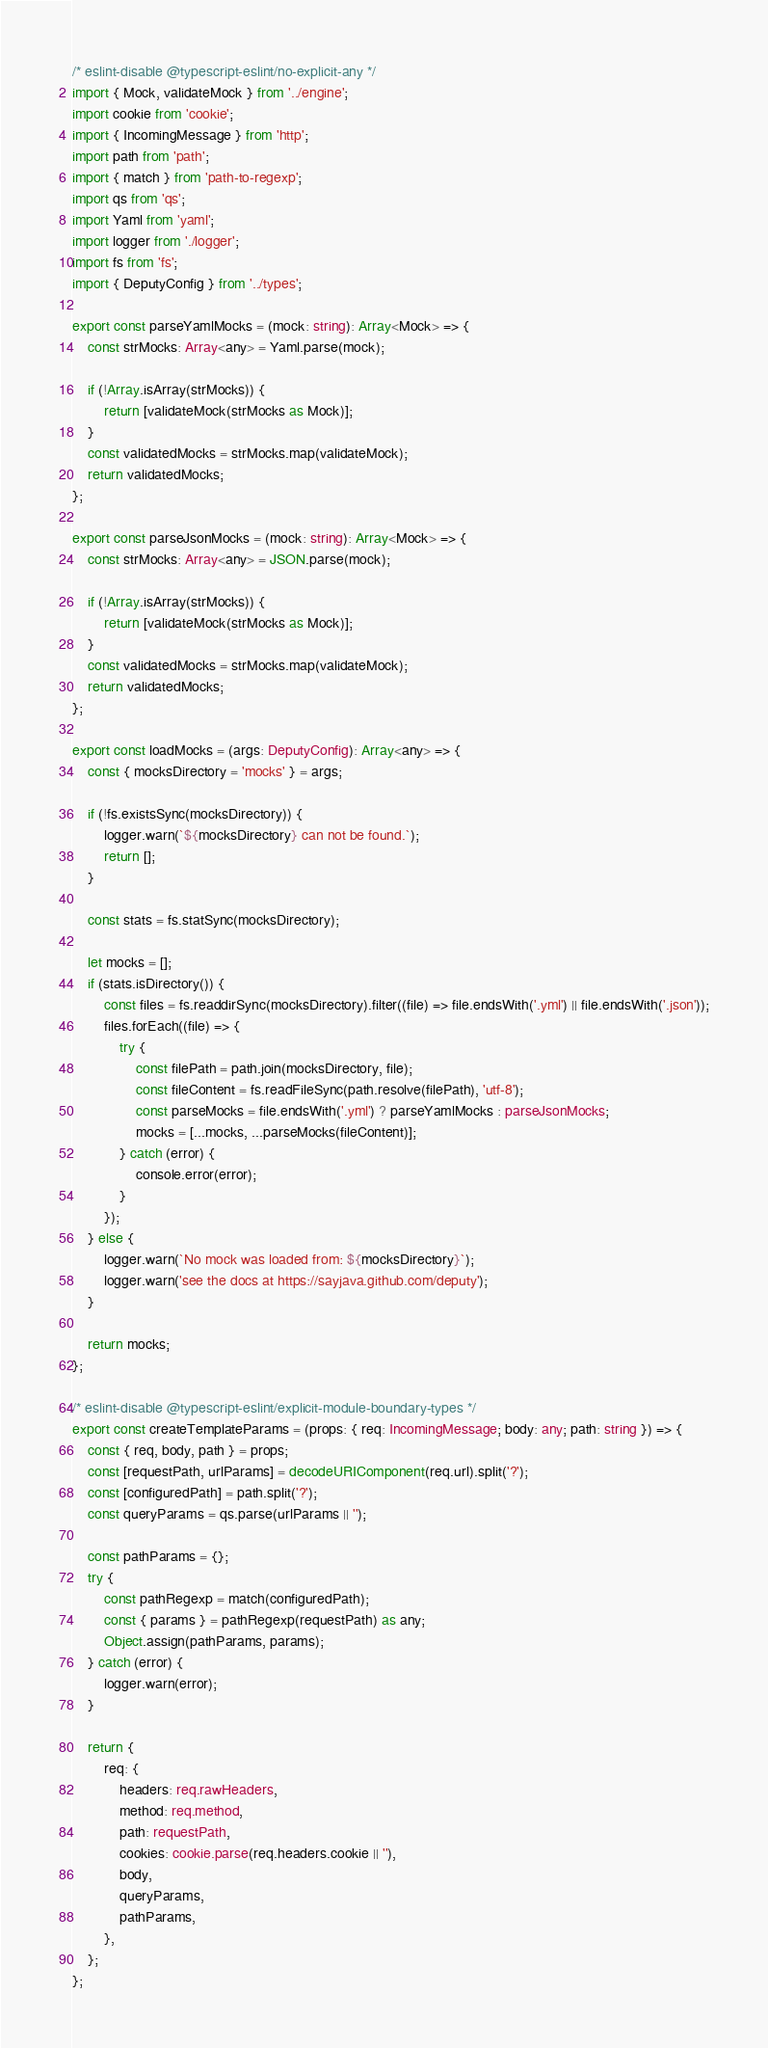<code> <loc_0><loc_0><loc_500><loc_500><_TypeScript_>/* eslint-disable @typescript-eslint/no-explicit-any */
import { Mock, validateMock } from '../engine';
import cookie from 'cookie';
import { IncomingMessage } from 'http';
import path from 'path';
import { match } from 'path-to-regexp';
import qs from 'qs';
import Yaml from 'yaml';
import logger from './logger';
import fs from 'fs';
import { DeputyConfig } from '../types';

export const parseYamlMocks = (mock: string): Array<Mock> => {
    const strMocks: Array<any> = Yaml.parse(mock);

    if (!Array.isArray(strMocks)) {
        return [validateMock(strMocks as Mock)];
    }
    const validatedMocks = strMocks.map(validateMock);
    return validatedMocks;
};

export const parseJsonMocks = (mock: string): Array<Mock> => {
    const strMocks: Array<any> = JSON.parse(mock);

    if (!Array.isArray(strMocks)) {
        return [validateMock(strMocks as Mock)];
    }
    const validatedMocks = strMocks.map(validateMock);
    return validatedMocks;
};

export const loadMocks = (args: DeputyConfig): Array<any> => {
    const { mocksDirectory = 'mocks' } = args;

    if (!fs.existsSync(mocksDirectory)) {
        logger.warn(`${mocksDirectory} can not be found.`);
        return [];
    }

    const stats = fs.statSync(mocksDirectory);

    let mocks = [];
    if (stats.isDirectory()) {
        const files = fs.readdirSync(mocksDirectory).filter((file) => file.endsWith('.yml') || file.endsWith('.json'));
        files.forEach((file) => {
            try {
                const filePath = path.join(mocksDirectory, file);
                const fileContent = fs.readFileSync(path.resolve(filePath), 'utf-8');
                const parseMocks = file.endsWith('.yml') ? parseYamlMocks : parseJsonMocks;
                mocks = [...mocks, ...parseMocks(fileContent)];
            } catch (error) {
                console.error(error);
            }
        });
    } else {
        logger.warn(`No mock was loaded from: ${mocksDirectory}`);
        logger.warn('see the docs at https://sayjava.github.com/deputy');
    }

    return mocks;
};

/* eslint-disable @typescript-eslint/explicit-module-boundary-types */
export const createTemplateParams = (props: { req: IncomingMessage; body: any; path: string }) => {
    const { req, body, path } = props;
    const [requestPath, urlParams] = decodeURIComponent(req.url).split('?');
    const [configuredPath] = path.split('?');
    const queryParams = qs.parse(urlParams || '');

    const pathParams = {};
    try {
        const pathRegexp = match(configuredPath);
        const { params } = pathRegexp(requestPath) as any;
        Object.assign(pathParams, params);
    } catch (error) {
        logger.warn(error);
    }

    return {
        req: {
            headers: req.rawHeaders,
            method: req.method,
            path: requestPath,
            cookies: cookie.parse(req.headers.cookie || ''),
            body,
            queryParams,
            pathParams,
        },
    };
};
</code> 